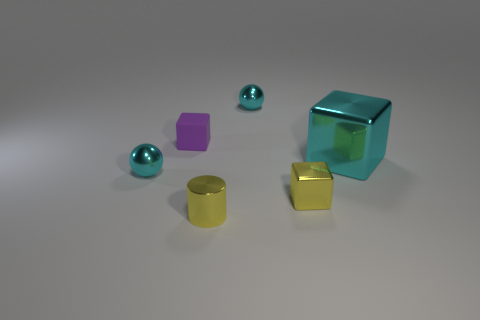How many objects are either purple things behind the yellow metal cylinder or big blue balls?
Make the answer very short. 1. There is a matte object; does it have the same size as the cyan ball that is behind the purple matte block?
Offer a terse response. Yes. What number of tiny objects are either cyan spheres or yellow blocks?
Provide a succinct answer. 3. What shape is the tiny matte object?
Your answer should be very brief. Cube. There is a cylinder that is the same color as the small shiny block; what is its size?
Provide a short and direct response. Small. Are there any tiny gray spheres made of the same material as the cyan block?
Give a very brief answer. No. Is the number of cyan cylinders greater than the number of large objects?
Provide a short and direct response. No. Are the large thing and the tiny cylinder made of the same material?
Offer a terse response. Yes. What number of shiny things are small blocks or cyan things?
Offer a very short reply. 4. What color is the block that is the same size as the rubber object?
Provide a short and direct response. Yellow. 